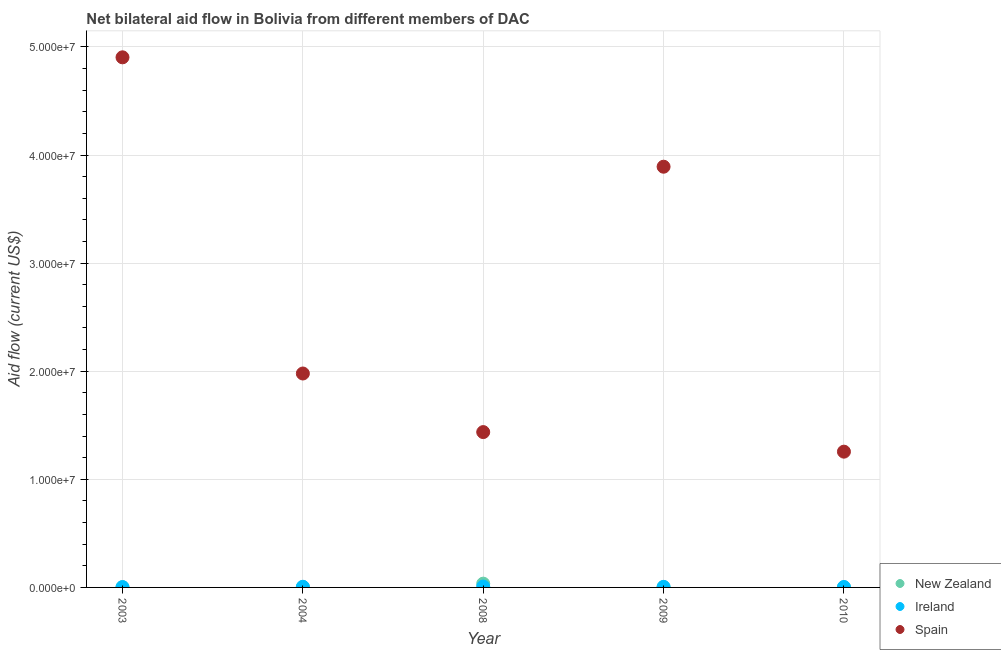How many different coloured dotlines are there?
Give a very brief answer. 3. What is the amount of aid provided by ireland in 2010?
Your response must be concise. 4.00e+04. Across all years, what is the maximum amount of aid provided by ireland?
Your answer should be compact. 8.00e+04. Across all years, what is the minimum amount of aid provided by ireland?
Your response must be concise. 3.00e+04. In which year was the amount of aid provided by ireland minimum?
Your response must be concise. 2003. What is the total amount of aid provided by spain in the graph?
Offer a terse response. 1.35e+08. What is the difference between the amount of aid provided by spain in 2003 and that in 2010?
Provide a short and direct response. 3.65e+07. What is the difference between the amount of aid provided by new zealand in 2003 and the amount of aid provided by ireland in 2009?
Ensure brevity in your answer.  -3.00e+04. What is the average amount of aid provided by new zealand per year?
Give a very brief answer. 8.80e+04. In the year 2009, what is the difference between the amount of aid provided by ireland and amount of aid provided by spain?
Your answer should be compact. -3.89e+07. In how many years, is the amount of aid provided by new zealand greater than 28000000 US$?
Make the answer very short. 0. What is the ratio of the amount of aid provided by ireland in 2009 to that in 2010?
Keep it short and to the point. 1.25. Is the amount of aid provided by spain in 2003 less than that in 2010?
Give a very brief answer. No. Is the difference between the amount of aid provided by new zealand in 2004 and 2009 greater than the difference between the amount of aid provided by ireland in 2004 and 2009?
Provide a succinct answer. No. What is the difference between the highest and the second highest amount of aid provided by ireland?
Provide a succinct answer. 2.00e+04. What is the difference between the highest and the lowest amount of aid provided by new zealand?
Your response must be concise. 3.40e+05. In how many years, is the amount of aid provided by spain greater than the average amount of aid provided by spain taken over all years?
Offer a terse response. 2. Is the sum of the amount of aid provided by new zealand in 2003 and 2004 greater than the maximum amount of aid provided by ireland across all years?
Keep it short and to the point. No. Does the amount of aid provided by ireland monotonically increase over the years?
Provide a succinct answer. No. Is the amount of aid provided by ireland strictly greater than the amount of aid provided by spain over the years?
Ensure brevity in your answer.  No. Is the amount of aid provided by new zealand strictly less than the amount of aid provided by spain over the years?
Keep it short and to the point. Yes. How many dotlines are there?
Your response must be concise. 3. How many years are there in the graph?
Keep it short and to the point. 5. Does the graph contain any zero values?
Make the answer very short. No. Does the graph contain grids?
Give a very brief answer. Yes. Where does the legend appear in the graph?
Keep it short and to the point. Bottom right. How many legend labels are there?
Your response must be concise. 3. What is the title of the graph?
Provide a short and direct response. Net bilateral aid flow in Bolivia from different members of DAC. Does "Central government" appear as one of the legend labels in the graph?
Offer a very short reply. No. What is the label or title of the X-axis?
Your answer should be compact. Year. What is the Aid flow (current US$) in New Zealand in 2003?
Provide a succinct answer. 2.00e+04. What is the Aid flow (current US$) in Ireland in 2003?
Keep it short and to the point. 3.00e+04. What is the Aid flow (current US$) of Spain in 2003?
Offer a terse response. 4.90e+07. What is the Aid flow (current US$) in Ireland in 2004?
Offer a terse response. 6.00e+04. What is the Aid flow (current US$) in Spain in 2004?
Offer a terse response. 1.98e+07. What is the Aid flow (current US$) of New Zealand in 2008?
Keep it short and to the point. 3.50e+05. What is the Aid flow (current US$) of Spain in 2008?
Your response must be concise. 1.44e+07. What is the Aid flow (current US$) of New Zealand in 2009?
Your answer should be very brief. 3.00e+04. What is the Aid flow (current US$) of Spain in 2009?
Give a very brief answer. 3.89e+07. What is the Aid flow (current US$) of Spain in 2010?
Provide a short and direct response. 1.26e+07. Across all years, what is the maximum Aid flow (current US$) in Ireland?
Provide a succinct answer. 8.00e+04. Across all years, what is the maximum Aid flow (current US$) of Spain?
Make the answer very short. 4.90e+07. Across all years, what is the minimum Aid flow (current US$) in Spain?
Provide a succinct answer. 1.26e+07. What is the total Aid flow (current US$) of New Zealand in the graph?
Provide a succinct answer. 4.40e+05. What is the total Aid flow (current US$) of Spain in the graph?
Your answer should be compact. 1.35e+08. What is the difference between the Aid flow (current US$) in New Zealand in 2003 and that in 2004?
Ensure brevity in your answer.  -10000. What is the difference between the Aid flow (current US$) in Spain in 2003 and that in 2004?
Make the answer very short. 2.92e+07. What is the difference between the Aid flow (current US$) of New Zealand in 2003 and that in 2008?
Provide a succinct answer. -3.30e+05. What is the difference between the Aid flow (current US$) in Ireland in 2003 and that in 2008?
Your answer should be very brief. -5.00e+04. What is the difference between the Aid flow (current US$) of Spain in 2003 and that in 2008?
Your answer should be compact. 3.47e+07. What is the difference between the Aid flow (current US$) in New Zealand in 2003 and that in 2009?
Your answer should be compact. -10000. What is the difference between the Aid flow (current US$) in Ireland in 2003 and that in 2009?
Your answer should be compact. -2.00e+04. What is the difference between the Aid flow (current US$) of Spain in 2003 and that in 2009?
Provide a succinct answer. 1.01e+07. What is the difference between the Aid flow (current US$) in Spain in 2003 and that in 2010?
Offer a very short reply. 3.65e+07. What is the difference between the Aid flow (current US$) in New Zealand in 2004 and that in 2008?
Make the answer very short. -3.20e+05. What is the difference between the Aid flow (current US$) of Ireland in 2004 and that in 2008?
Provide a short and direct response. -2.00e+04. What is the difference between the Aid flow (current US$) of Spain in 2004 and that in 2008?
Your response must be concise. 5.42e+06. What is the difference between the Aid flow (current US$) in Spain in 2004 and that in 2009?
Provide a succinct answer. -1.91e+07. What is the difference between the Aid flow (current US$) of New Zealand in 2004 and that in 2010?
Your answer should be compact. 2.00e+04. What is the difference between the Aid flow (current US$) of Ireland in 2004 and that in 2010?
Offer a very short reply. 2.00e+04. What is the difference between the Aid flow (current US$) of Spain in 2004 and that in 2010?
Your answer should be very brief. 7.23e+06. What is the difference between the Aid flow (current US$) in New Zealand in 2008 and that in 2009?
Provide a short and direct response. 3.20e+05. What is the difference between the Aid flow (current US$) of Spain in 2008 and that in 2009?
Provide a short and direct response. -2.46e+07. What is the difference between the Aid flow (current US$) of New Zealand in 2008 and that in 2010?
Provide a short and direct response. 3.40e+05. What is the difference between the Aid flow (current US$) of Spain in 2008 and that in 2010?
Give a very brief answer. 1.81e+06. What is the difference between the Aid flow (current US$) of Spain in 2009 and that in 2010?
Provide a succinct answer. 2.64e+07. What is the difference between the Aid flow (current US$) in New Zealand in 2003 and the Aid flow (current US$) in Ireland in 2004?
Keep it short and to the point. -4.00e+04. What is the difference between the Aid flow (current US$) in New Zealand in 2003 and the Aid flow (current US$) in Spain in 2004?
Ensure brevity in your answer.  -1.98e+07. What is the difference between the Aid flow (current US$) in Ireland in 2003 and the Aid flow (current US$) in Spain in 2004?
Keep it short and to the point. -1.98e+07. What is the difference between the Aid flow (current US$) of New Zealand in 2003 and the Aid flow (current US$) of Spain in 2008?
Your answer should be very brief. -1.44e+07. What is the difference between the Aid flow (current US$) in Ireland in 2003 and the Aid flow (current US$) in Spain in 2008?
Keep it short and to the point. -1.43e+07. What is the difference between the Aid flow (current US$) in New Zealand in 2003 and the Aid flow (current US$) in Ireland in 2009?
Give a very brief answer. -3.00e+04. What is the difference between the Aid flow (current US$) of New Zealand in 2003 and the Aid flow (current US$) of Spain in 2009?
Provide a short and direct response. -3.89e+07. What is the difference between the Aid flow (current US$) of Ireland in 2003 and the Aid flow (current US$) of Spain in 2009?
Make the answer very short. -3.89e+07. What is the difference between the Aid flow (current US$) of New Zealand in 2003 and the Aid flow (current US$) of Spain in 2010?
Your answer should be very brief. -1.25e+07. What is the difference between the Aid flow (current US$) in Ireland in 2003 and the Aid flow (current US$) in Spain in 2010?
Keep it short and to the point. -1.25e+07. What is the difference between the Aid flow (current US$) in New Zealand in 2004 and the Aid flow (current US$) in Spain in 2008?
Your response must be concise. -1.43e+07. What is the difference between the Aid flow (current US$) in Ireland in 2004 and the Aid flow (current US$) in Spain in 2008?
Make the answer very short. -1.43e+07. What is the difference between the Aid flow (current US$) in New Zealand in 2004 and the Aid flow (current US$) in Spain in 2009?
Offer a terse response. -3.89e+07. What is the difference between the Aid flow (current US$) of Ireland in 2004 and the Aid flow (current US$) of Spain in 2009?
Your response must be concise. -3.89e+07. What is the difference between the Aid flow (current US$) of New Zealand in 2004 and the Aid flow (current US$) of Spain in 2010?
Your answer should be very brief. -1.25e+07. What is the difference between the Aid flow (current US$) in Ireland in 2004 and the Aid flow (current US$) in Spain in 2010?
Ensure brevity in your answer.  -1.25e+07. What is the difference between the Aid flow (current US$) of New Zealand in 2008 and the Aid flow (current US$) of Ireland in 2009?
Offer a very short reply. 3.00e+05. What is the difference between the Aid flow (current US$) of New Zealand in 2008 and the Aid flow (current US$) of Spain in 2009?
Offer a very short reply. -3.86e+07. What is the difference between the Aid flow (current US$) of Ireland in 2008 and the Aid flow (current US$) of Spain in 2009?
Keep it short and to the point. -3.88e+07. What is the difference between the Aid flow (current US$) of New Zealand in 2008 and the Aid flow (current US$) of Ireland in 2010?
Give a very brief answer. 3.10e+05. What is the difference between the Aid flow (current US$) of New Zealand in 2008 and the Aid flow (current US$) of Spain in 2010?
Your answer should be compact. -1.22e+07. What is the difference between the Aid flow (current US$) of Ireland in 2008 and the Aid flow (current US$) of Spain in 2010?
Keep it short and to the point. -1.25e+07. What is the difference between the Aid flow (current US$) in New Zealand in 2009 and the Aid flow (current US$) in Spain in 2010?
Make the answer very short. -1.25e+07. What is the difference between the Aid flow (current US$) in Ireland in 2009 and the Aid flow (current US$) in Spain in 2010?
Your response must be concise. -1.25e+07. What is the average Aid flow (current US$) in New Zealand per year?
Offer a terse response. 8.80e+04. What is the average Aid flow (current US$) of Ireland per year?
Your answer should be very brief. 5.20e+04. What is the average Aid flow (current US$) of Spain per year?
Your response must be concise. 2.69e+07. In the year 2003, what is the difference between the Aid flow (current US$) in New Zealand and Aid flow (current US$) in Ireland?
Provide a succinct answer. -10000. In the year 2003, what is the difference between the Aid flow (current US$) in New Zealand and Aid flow (current US$) in Spain?
Make the answer very short. -4.90e+07. In the year 2003, what is the difference between the Aid flow (current US$) of Ireland and Aid flow (current US$) of Spain?
Your answer should be very brief. -4.90e+07. In the year 2004, what is the difference between the Aid flow (current US$) in New Zealand and Aid flow (current US$) in Spain?
Offer a terse response. -1.98e+07. In the year 2004, what is the difference between the Aid flow (current US$) of Ireland and Aid flow (current US$) of Spain?
Provide a short and direct response. -1.97e+07. In the year 2008, what is the difference between the Aid flow (current US$) in New Zealand and Aid flow (current US$) in Ireland?
Offer a terse response. 2.70e+05. In the year 2008, what is the difference between the Aid flow (current US$) of New Zealand and Aid flow (current US$) of Spain?
Give a very brief answer. -1.40e+07. In the year 2008, what is the difference between the Aid flow (current US$) in Ireland and Aid flow (current US$) in Spain?
Your answer should be compact. -1.43e+07. In the year 2009, what is the difference between the Aid flow (current US$) of New Zealand and Aid flow (current US$) of Spain?
Provide a succinct answer. -3.89e+07. In the year 2009, what is the difference between the Aid flow (current US$) of Ireland and Aid flow (current US$) of Spain?
Give a very brief answer. -3.89e+07. In the year 2010, what is the difference between the Aid flow (current US$) of New Zealand and Aid flow (current US$) of Spain?
Give a very brief answer. -1.26e+07. In the year 2010, what is the difference between the Aid flow (current US$) in Ireland and Aid flow (current US$) in Spain?
Offer a terse response. -1.25e+07. What is the ratio of the Aid flow (current US$) in Spain in 2003 to that in 2004?
Your response must be concise. 2.48. What is the ratio of the Aid flow (current US$) in New Zealand in 2003 to that in 2008?
Your answer should be very brief. 0.06. What is the ratio of the Aid flow (current US$) of Ireland in 2003 to that in 2008?
Give a very brief answer. 0.38. What is the ratio of the Aid flow (current US$) in Spain in 2003 to that in 2008?
Provide a short and direct response. 3.41. What is the ratio of the Aid flow (current US$) in New Zealand in 2003 to that in 2009?
Your answer should be compact. 0.67. What is the ratio of the Aid flow (current US$) in Ireland in 2003 to that in 2009?
Keep it short and to the point. 0.6. What is the ratio of the Aid flow (current US$) in Spain in 2003 to that in 2009?
Provide a succinct answer. 1.26. What is the ratio of the Aid flow (current US$) of Ireland in 2003 to that in 2010?
Make the answer very short. 0.75. What is the ratio of the Aid flow (current US$) of Spain in 2003 to that in 2010?
Your response must be concise. 3.9. What is the ratio of the Aid flow (current US$) of New Zealand in 2004 to that in 2008?
Provide a succinct answer. 0.09. What is the ratio of the Aid flow (current US$) in Spain in 2004 to that in 2008?
Your answer should be very brief. 1.38. What is the ratio of the Aid flow (current US$) of New Zealand in 2004 to that in 2009?
Provide a short and direct response. 1. What is the ratio of the Aid flow (current US$) in Ireland in 2004 to that in 2009?
Make the answer very short. 1.2. What is the ratio of the Aid flow (current US$) in Spain in 2004 to that in 2009?
Give a very brief answer. 0.51. What is the ratio of the Aid flow (current US$) of Ireland in 2004 to that in 2010?
Offer a terse response. 1.5. What is the ratio of the Aid flow (current US$) of Spain in 2004 to that in 2010?
Your answer should be very brief. 1.58. What is the ratio of the Aid flow (current US$) in New Zealand in 2008 to that in 2009?
Give a very brief answer. 11.67. What is the ratio of the Aid flow (current US$) of Spain in 2008 to that in 2009?
Your answer should be compact. 0.37. What is the ratio of the Aid flow (current US$) in Ireland in 2008 to that in 2010?
Your answer should be compact. 2. What is the ratio of the Aid flow (current US$) of Spain in 2008 to that in 2010?
Provide a succinct answer. 1.14. What is the ratio of the Aid flow (current US$) in Spain in 2009 to that in 2010?
Your answer should be compact. 3.1. What is the difference between the highest and the second highest Aid flow (current US$) in Spain?
Your response must be concise. 1.01e+07. What is the difference between the highest and the lowest Aid flow (current US$) of Ireland?
Offer a terse response. 5.00e+04. What is the difference between the highest and the lowest Aid flow (current US$) of Spain?
Offer a terse response. 3.65e+07. 